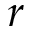<formula> <loc_0><loc_0><loc_500><loc_500>r</formula> 